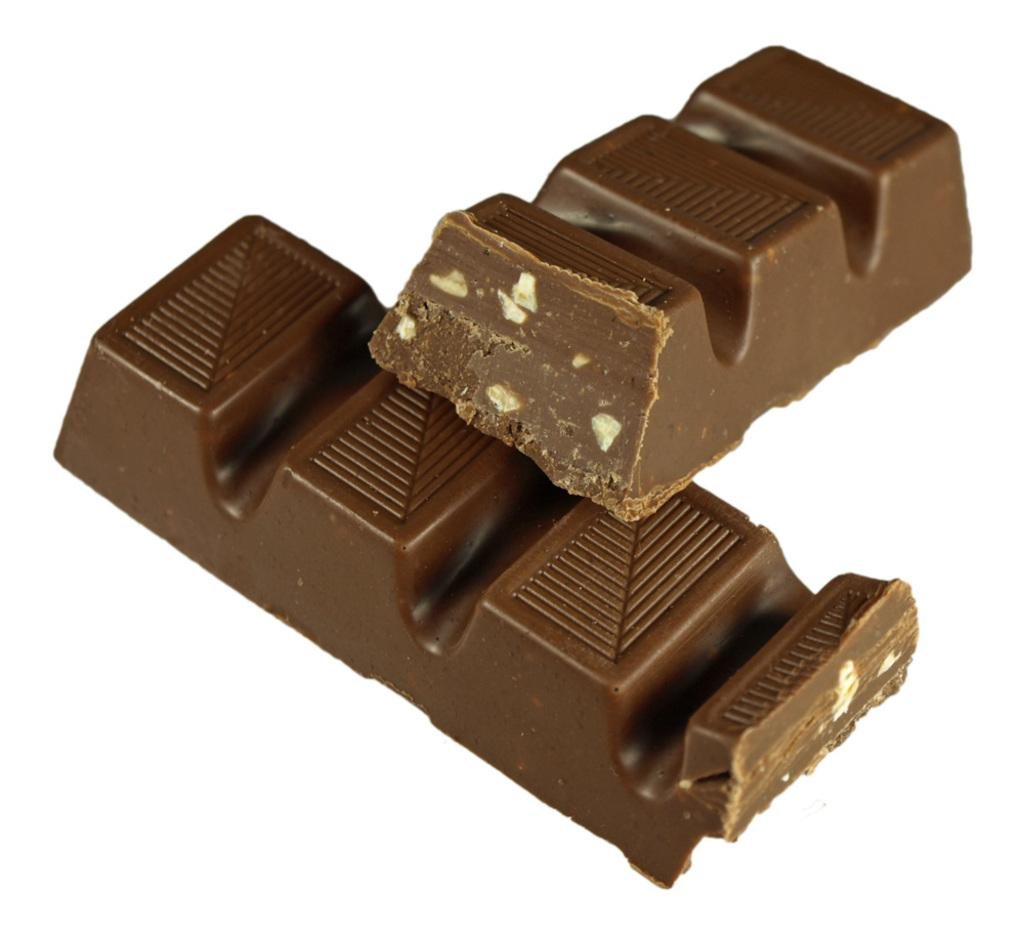What type of food is present in the image? There are chocolates in the image. What is the color of the chocolates? The chocolates are brown in color. What is the color of the surface on which the chocolates are placed? The chocolates are on a white surface. What type of apple is being held by the grandmother in the image? There is no grandmother or apple present in the image; it only features chocolates on a white surface. 